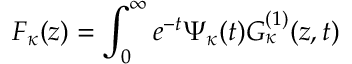Convert formula to latex. <formula><loc_0><loc_0><loc_500><loc_500>F _ { \kappa } ( z ) = \int _ { 0 } ^ { \infty } e ^ { - t } \Psi _ { \kappa } ( t ) G _ { \kappa } ^ { ( 1 ) } ( z , t )</formula> 